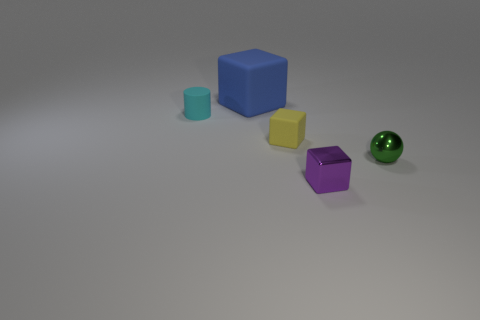Are there any brown metallic cylinders that have the same size as the green metallic object?
Your answer should be compact. No. Is the number of small yellow rubber things that are to the right of the yellow matte object greater than the number of tiny matte cylinders to the left of the metal block?
Offer a very short reply. No. Are the green object and the block behind the tiny cyan rubber cylinder made of the same material?
Provide a succinct answer. No. There is a matte object right of the matte cube behind the tiny cyan cylinder; how many blue rubber things are on the right side of it?
Keep it short and to the point. 0. There is a large rubber thing; does it have the same shape as the rubber thing that is in front of the small cyan thing?
Keep it short and to the point. Yes. There is a block that is in front of the large thing and behind the green shiny ball; what is its color?
Provide a succinct answer. Yellow. The cube that is behind the small object to the left of the matte block left of the tiny yellow object is made of what material?
Your response must be concise. Rubber. What is the material of the small purple cube?
Make the answer very short. Metal. There is a blue thing that is the same shape as the small yellow matte object; what size is it?
Your answer should be very brief. Large. How many other things are there of the same material as the cyan cylinder?
Provide a succinct answer. 2. 